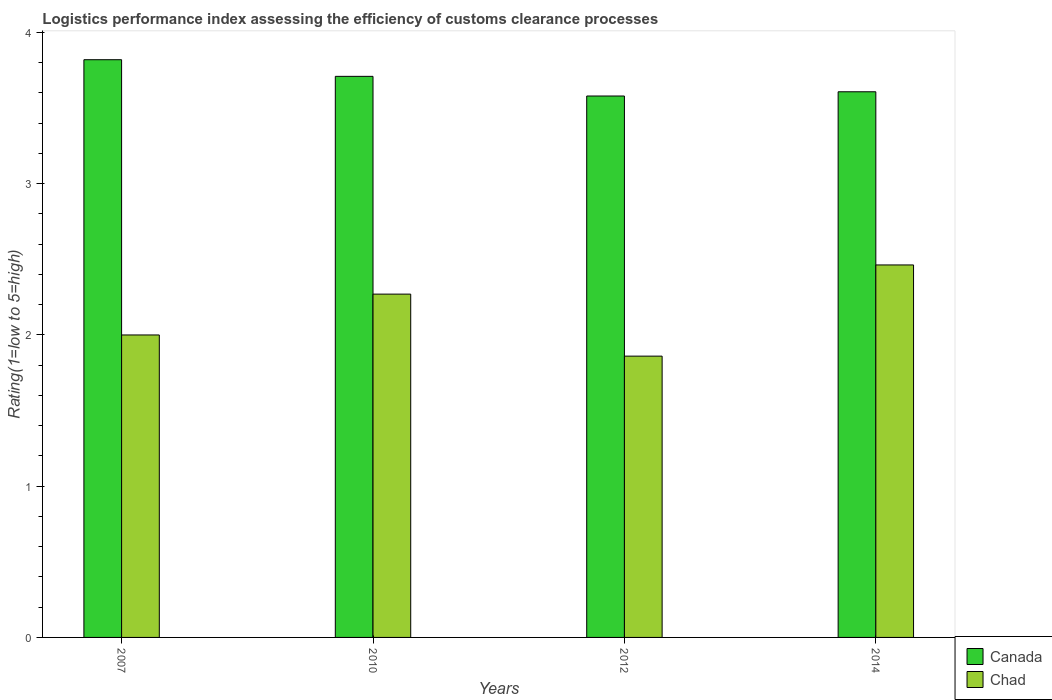How many groups of bars are there?
Keep it short and to the point. 4. Are the number of bars per tick equal to the number of legend labels?
Offer a very short reply. Yes. What is the Logistic performance index in Chad in 2014?
Offer a terse response. 2.46. Across all years, what is the maximum Logistic performance index in Chad?
Make the answer very short. 2.46. Across all years, what is the minimum Logistic performance index in Chad?
Provide a succinct answer. 1.86. In which year was the Logistic performance index in Canada minimum?
Make the answer very short. 2012. What is the total Logistic performance index in Chad in the graph?
Provide a succinct answer. 8.59. What is the difference between the Logistic performance index in Chad in 2007 and that in 2014?
Your answer should be compact. -0.46. What is the difference between the Logistic performance index in Chad in 2010 and the Logistic performance index in Canada in 2012?
Keep it short and to the point. -1.31. What is the average Logistic performance index in Chad per year?
Keep it short and to the point. 2.15. In the year 2007, what is the difference between the Logistic performance index in Canada and Logistic performance index in Chad?
Provide a short and direct response. 1.82. In how many years, is the Logistic performance index in Chad greater than 3.4?
Your answer should be very brief. 0. What is the ratio of the Logistic performance index in Chad in 2010 to that in 2012?
Keep it short and to the point. 1.22. Is the Logistic performance index in Canada in 2007 less than that in 2010?
Keep it short and to the point. No. What is the difference between the highest and the second highest Logistic performance index in Chad?
Provide a short and direct response. 0.19. What is the difference between the highest and the lowest Logistic performance index in Canada?
Your answer should be very brief. 0.24. Is the sum of the Logistic performance index in Chad in 2007 and 2010 greater than the maximum Logistic performance index in Canada across all years?
Provide a succinct answer. Yes. What does the 2nd bar from the right in 2010 represents?
Offer a terse response. Canada. Are the values on the major ticks of Y-axis written in scientific E-notation?
Offer a very short reply. No. Does the graph contain grids?
Your answer should be very brief. No. What is the title of the graph?
Your answer should be very brief. Logistics performance index assessing the efficiency of customs clearance processes. Does "Turkey" appear as one of the legend labels in the graph?
Make the answer very short. No. What is the label or title of the X-axis?
Make the answer very short. Years. What is the label or title of the Y-axis?
Ensure brevity in your answer.  Rating(1=low to 5=high). What is the Rating(1=low to 5=high) of Canada in 2007?
Ensure brevity in your answer.  3.82. What is the Rating(1=low to 5=high) in Canada in 2010?
Provide a succinct answer. 3.71. What is the Rating(1=low to 5=high) of Chad in 2010?
Make the answer very short. 2.27. What is the Rating(1=low to 5=high) of Canada in 2012?
Provide a short and direct response. 3.58. What is the Rating(1=low to 5=high) of Chad in 2012?
Make the answer very short. 1.86. What is the Rating(1=low to 5=high) in Canada in 2014?
Offer a very short reply. 3.61. What is the Rating(1=low to 5=high) in Chad in 2014?
Offer a very short reply. 2.46. Across all years, what is the maximum Rating(1=low to 5=high) in Canada?
Keep it short and to the point. 3.82. Across all years, what is the maximum Rating(1=low to 5=high) in Chad?
Keep it short and to the point. 2.46. Across all years, what is the minimum Rating(1=low to 5=high) in Canada?
Offer a terse response. 3.58. Across all years, what is the minimum Rating(1=low to 5=high) of Chad?
Offer a very short reply. 1.86. What is the total Rating(1=low to 5=high) of Canada in the graph?
Make the answer very short. 14.72. What is the total Rating(1=low to 5=high) of Chad in the graph?
Your answer should be compact. 8.59. What is the difference between the Rating(1=low to 5=high) in Canada in 2007 and that in 2010?
Keep it short and to the point. 0.11. What is the difference between the Rating(1=low to 5=high) in Chad in 2007 and that in 2010?
Your response must be concise. -0.27. What is the difference between the Rating(1=low to 5=high) in Canada in 2007 and that in 2012?
Keep it short and to the point. 0.24. What is the difference between the Rating(1=low to 5=high) in Chad in 2007 and that in 2012?
Your answer should be compact. 0.14. What is the difference between the Rating(1=low to 5=high) in Canada in 2007 and that in 2014?
Provide a short and direct response. 0.21. What is the difference between the Rating(1=low to 5=high) in Chad in 2007 and that in 2014?
Keep it short and to the point. -0.46. What is the difference between the Rating(1=low to 5=high) in Canada in 2010 and that in 2012?
Your answer should be compact. 0.13. What is the difference between the Rating(1=low to 5=high) in Chad in 2010 and that in 2012?
Your answer should be compact. 0.41. What is the difference between the Rating(1=low to 5=high) of Canada in 2010 and that in 2014?
Offer a very short reply. 0.1. What is the difference between the Rating(1=low to 5=high) of Chad in 2010 and that in 2014?
Your response must be concise. -0.19. What is the difference between the Rating(1=low to 5=high) of Canada in 2012 and that in 2014?
Provide a succinct answer. -0.03. What is the difference between the Rating(1=low to 5=high) in Chad in 2012 and that in 2014?
Offer a terse response. -0.6. What is the difference between the Rating(1=low to 5=high) of Canada in 2007 and the Rating(1=low to 5=high) of Chad in 2010?
Keep it short and to the point. 1.55. What is the difference between the Rating(1=low to 5=high) in Canada in 2007 and the Rating(1=low to 5=high) in Chad in 2012?
Keep it short and to the point. 1.96. What is the difference between the Rating(1=low to 5=high) of Canada in 2007 and the Rating(1=low to 5=high) of Chad in 2014?
Provide a succinct answer. 1.36. What is the difference between the Rating(1=low to 5=high) of Canada in 2010 and the Rating(1=low to 5=high) of Chad in 2012?
Keep it short and to the point. 1.85. What is the difference between the Rating(1=low to 5=high) of Canada in 2010 and the Rating(1=low to 5=high) of Chad in 2014?
Your answer should be very brief. 1.25. What is the difference between the Rating(1=low to 5=high) of Canada in 2012 and the Rating(1=low to 5=high) of Chad in 2014?
Make the answer very short. 1.12. What is the average Rating(1=low to 5=high) of Canada per year?
Provide a short and direct response. 3.68. What is the average Rating(1=low to 5=high) of Chad per year?
Ensure brevity in your answer.  2.15. In the year 2007, what is the difference between the Rating(1=low to 5=high) in Canada and Rating(1=low to 5=high) in Chad?
Make the answer very short. 1.82. In the year 2010, what is the difference between the Rating(1=low to 5=high) of Canada and Rating(1=low to 5=high) of Chad?
Offer a terse response. 1.44. In the year 2012, what is the difference between the Rating(1=low to 5=high) in Canada and Rating(1=low to 5=high) in Chad?
Provide a succinct answer. 1.72. In the year 2014, what is the difference between the Rating(1=low to 5=high) of Canada and Rating(1=low to 5=high) of Chad?
Provide a succinct answer. 1.15. What is the ratio of the Rating(1=low to 5=high) in Canada in 2007 to that in 2010?
Offer a terse response. 1.03. What is the ratio of the Rating(1=low to 5=high) in Chad in 2007 to that in 2010?
Your response must be concise. 0.88. What is the ratio of the Rating(1=low to 5=high) of Canada in 2007 to that in 2012?
Provide a short and direct response. 1.07. What is the ratio of the Rating(1=low to 5=high) in Chad in 2007 to that in 2012?
Offer a terse response. 1.08. What is the ratio of the Rating(1=low to 5=high) in Canada in 2007 to that in 2014?
Offer a very short reply. 1.06. What is the ratio of the Rating(1=low to 5=high) in Chad in 2007 to that in 2014?
Your answer should be compact. 0.81. What is the ratio of the Rating(1=low to 5=high) of Canada in 2010 to that in 2012?
Ensure brevity in your answer.  1.04. What is the ratio of the Rating(1=low to 5=high) of Chad in 2010 to that in 2012?
Offer a very short reply. 1.22. What is the ratio of the Rating(1=low to 5=high) of Canada in 2010 to that in 2014?
Your answer should be very brief. 1.03. What is the ratio of the Rating(1=low to 5=high) in Chad in 2010 to that in 2014?
Your answer should be compact. 0.92. What is the ratio of the Rating(1=low to 5=high) in Canada in 2012 to that in 2014?
Provide a succinct answer. 0.99. What is the ratio of the Rating(1=low to 5=high) of Chad in 2012 to that in 2014?
Your answer should be compact. 0.76. What is the difference between the highest and the second highest Rating(1=low to 5=high) of Canada?
Your response must be concise. 0.11. What is the difference between the highest and the second highest Rating(1=low to 5=high) of Chad?
Give a very brief answer. 0.19. What is the difference between the highest and the lowest Rating(1=low to 5=high) of Canada?
Your answer should be compact. 0.24. What is the difference between the highest and the lowest Rating(1=low to 5=high) in Chad?
Keep it short and to the point. 0.6. 